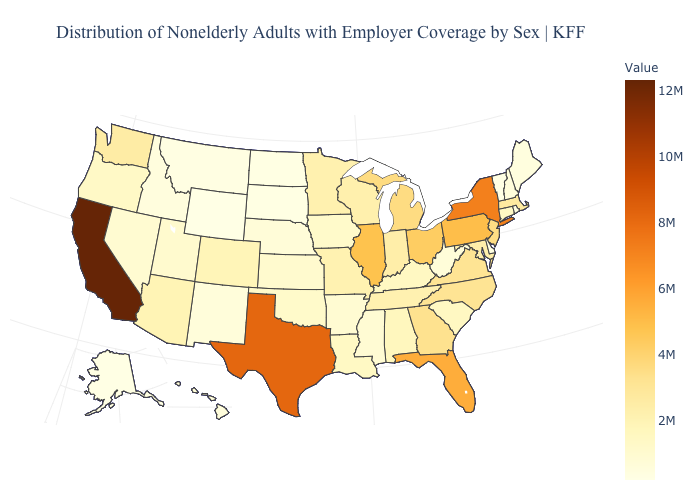Which states have the lowest value in the USA?
Short answer required. Wyoming. Among the states that border South Dakota , which have the lowest value?
Short answer required. Wyoming. Does Minnesota have the lowest value in the MidWest?
Short answer required. No. Does Wyoming have the lowest value in the USA?
Answer briefly. Yes. 